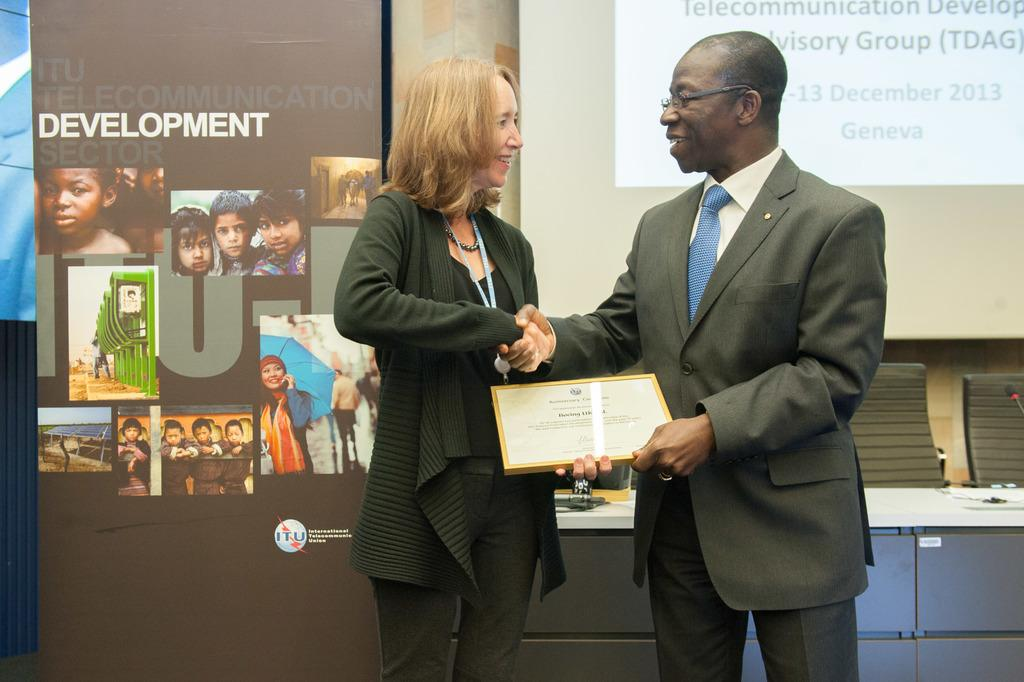What are the two people in the image doing? The two people are standing and smiling. What are the two people holding in the image? The two people are holding a frame. What can be seen in the background of the image? There is a banner and a screen in the background. What is present on the table in the image? There are objects on a table. How many times does the person on the left sneeze in the image? There is no indication in the image that anyone is sneezing, so it cannot be determined. 